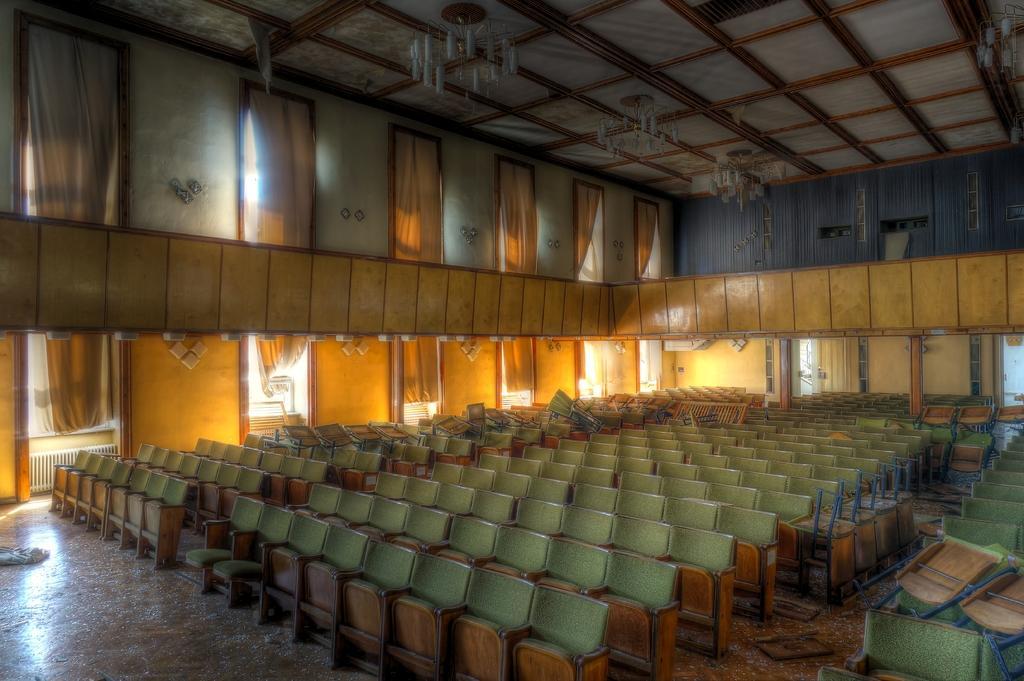Could you give a brief overview of what you see in this image? In this picture we can see chairs on the path and behind the chairs there's a wall with curtains. At the top there are chandeliers. 